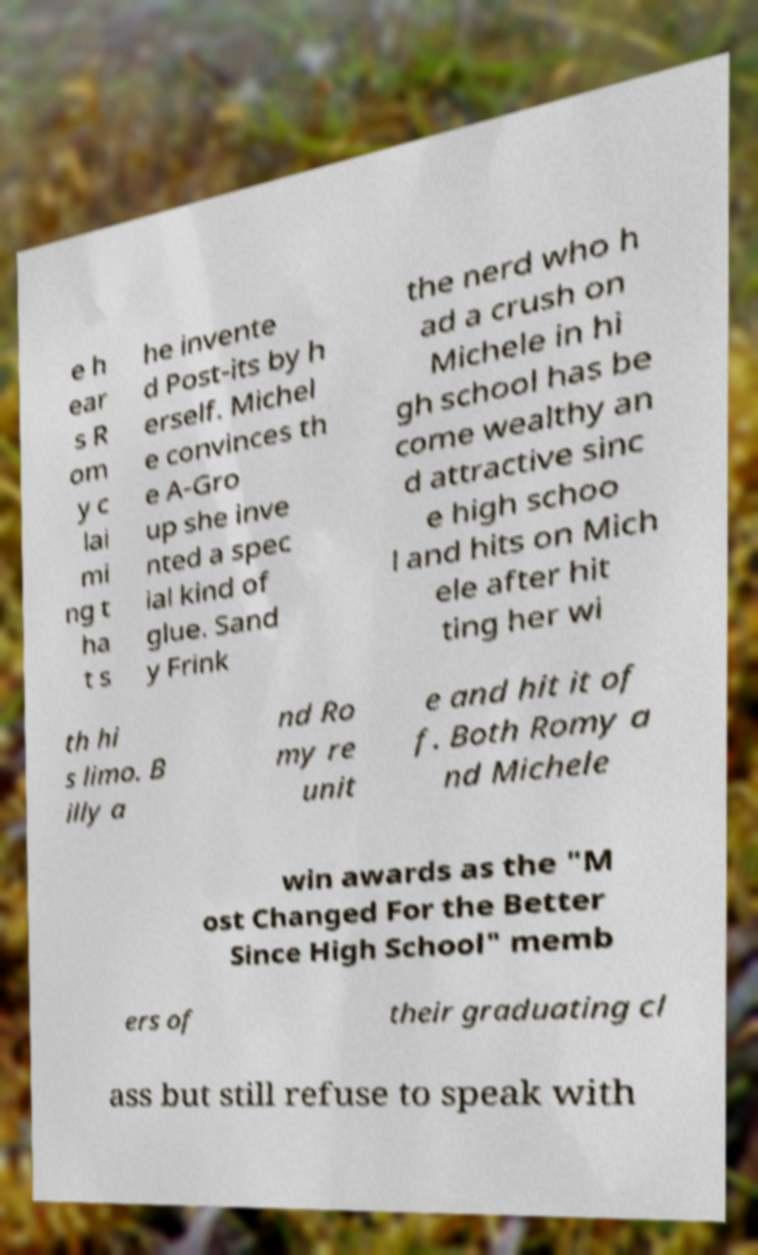Please read and relay the text visible in this image. What does it say? e h ear s R om y c lai mi ng t ha t s he invente d Post-its by h erself. Michel e convinces th e A-Gro up she inve nted a spec ial kind of glue. Sand y Frink the nerd who h ad a crush on Michele in hi gh school has be come wealthy an d attractive sinc e high schoo l and hits on Mich ele after hit ting her wi th hi s limo. B illy a nd Ro my re unit e and hit it of f. Both Romy a nd Michele win awards as the "M ost Changed For the Better Since High School" memb ers of their graduating cl ass but still refuse to speak with 